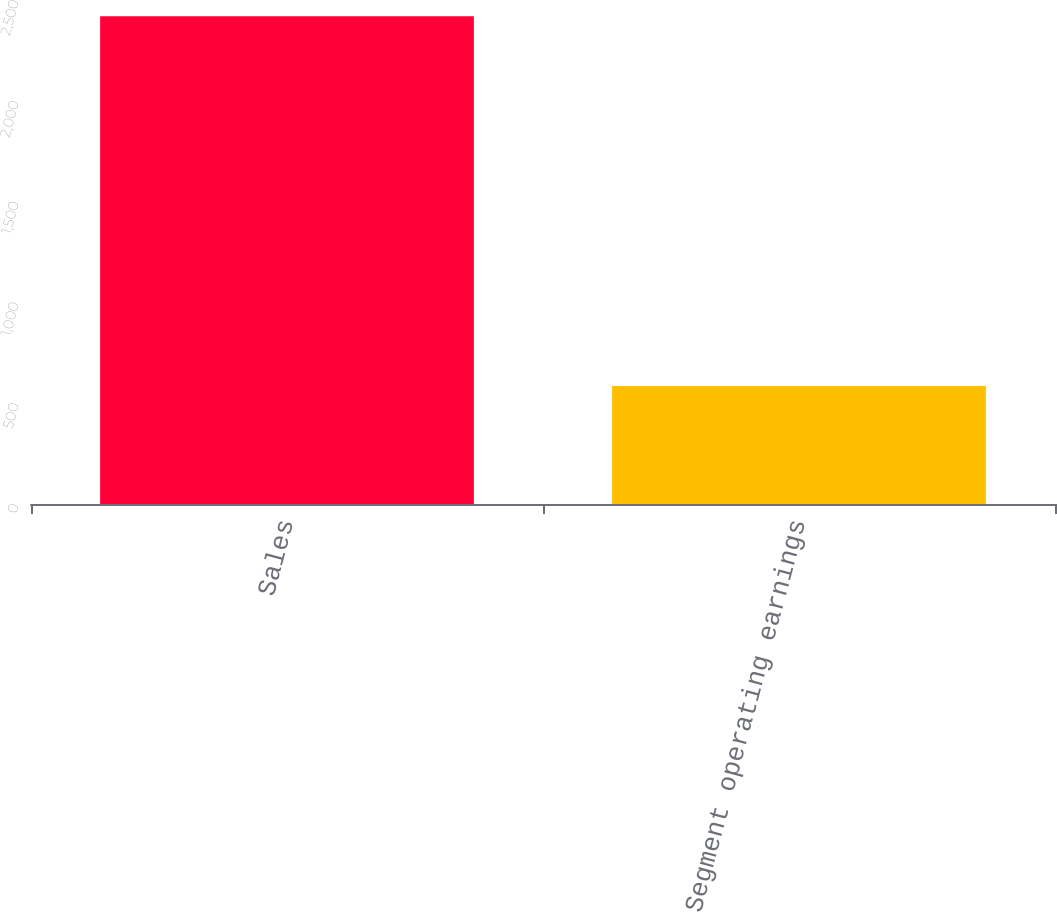<chart> <loc_0><loc_0><loc_500><loc_500><bar_chart><fcel>Sales<fcel>Segment operating earnings<nl><fcel>2419.7<fcel>584.7<nl></chart> 